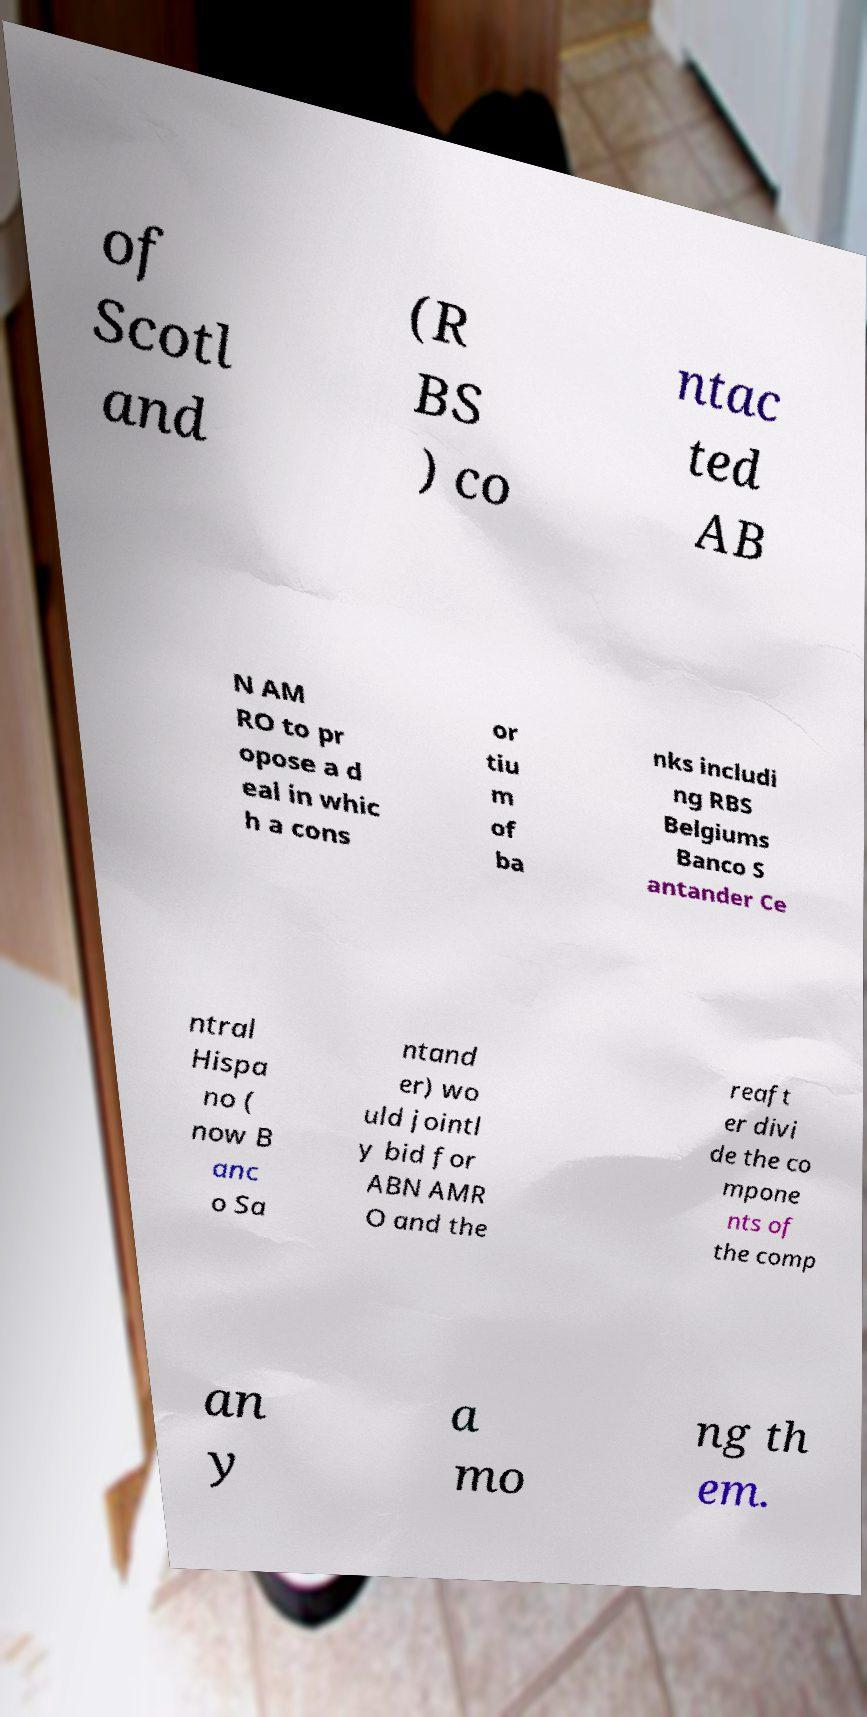I need the written content from this picture converted into text. Can you do that? of Scotl and (R BS ) co ntac ted AB N AM RO to pr opose a d eal in whic h a cons or tiu m of ba nks includi ng RBS Belgiums Banco S antander Ce ntral Hispa no ( now B anc o Sa ntand er) wo uld jointl y bid for ABN AMR O and the reaft er divi de the co mpone nts of the comp an y a mo ng th em. 